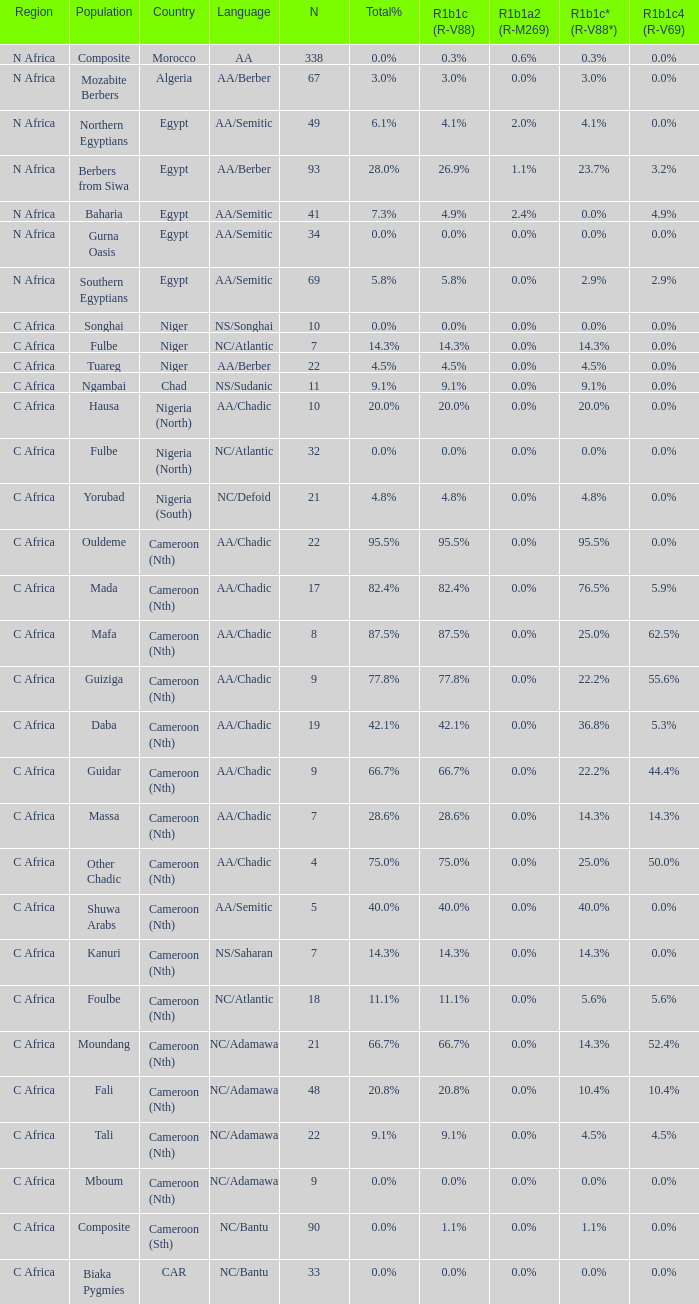What languages are spoken in Niger with r1b1c (r-v88) of 0.0%? NS/Songhai. 